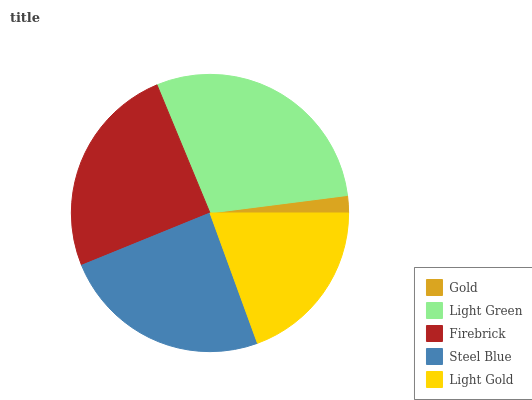Is Gold the minimum?
Answer yes or no. Yes. Is Light Green the maximum?
Answer yes or no. Yes. Is Firebrick the minimum?
Answer yes or no. No. Is Firebrick the maximum?
Answer yes or no. No. Is Light Green greater than Firebrick?
Answer yes or no. Yes. Is Firebrick less than Light Green?
Answer yes or no. Yes. Is Firebrick greater than Light Green?
Answer yes or no. No. Is Light Green less than Firebrick?
Answer yes or no. No. Is Steel Blue the high median?
Answer yes or no. Yes. Is Steel Blue the low median?
Answer yes or no. Yes. Is Light Gold the high median?
Answer yes or no. No. Is Light Gold the low median?
Answer yes or no. No. 